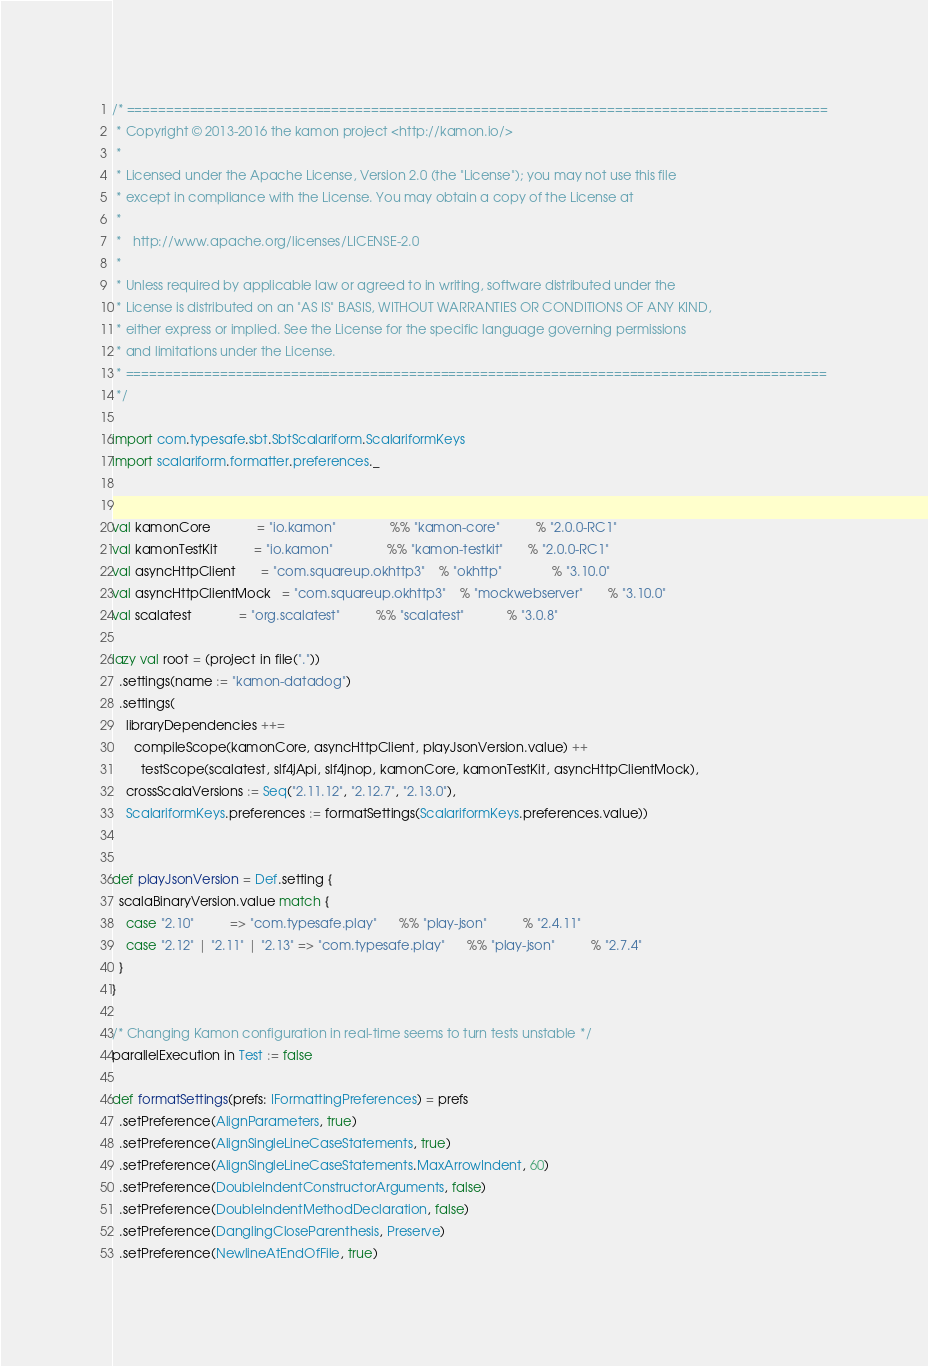<code> <loc_0><loc_0><loc_500><loc_500><_Scala_>/* =========================================================================================
 * Copyright © 2013-2016 the kamon project <http://kamon.io/>
 *
 * Licensed under the Apache License, Version 2.0 (the "License"); you may not use this file
 * except in compliance with the License. You may obtain a copy of the License at
 *
 *   http://www.apache.org/licenses/LICENSE-2.0
 *
 * Unless required by applicable law or agreed to in writing, software distributed under the
 * License is distributed on an "AS IS" BASIS, WITHOUT WARRANTIES OR CONDITIONS OF ANY KIND,
 * either express or implied. See the License for the specific language governing permissions
 * and limitations under the License.
 * =========================================================================================
 */

import com.typesafe.sbt.SbtScalariform.ScalariformKeys
import scalariform.formatter.preferences._


val kamonCore             = "io.kamon"               %% "kamon-core"          % "2.0.0-RC1"
val kamonTestKit          = "io.kamon"               %% "kamon-testkit"       % "2.0.0-RC1"
val asyncHttpClient       = "com.squareup.okhttp3"    % "okhttp"              % "3.10.0"
val asyncHttpClientMock   = "com.squareup.okhttp3"    % "mockwebserver"       % "3.10.0"
val scalatest             = "org.scalatest"          %% "scalatest"            % "3.0.8"

lazy val root = (project in file("."))
  .settings(name := "kamon-datadog")
  .settings(
    libraryDependencies ++=
      compileScope(kamonCore, asyncHttpClient, playJsonVersion.value) ++
        testScope(scalatest, slf4jApi, slf4jnop, kamonCore, kamonTestKit, asyncHttpClientMock),
    crossScalaVersions := Seq("2.11.12", "2.12.7", "2.13.0"),
    ScalariformKeys.preferences := formatSettings(ScalariformKeys.preferences.value))


def playJsonVersion = Def.setting {
  scalaBinaryVersion.value match {
    case "2.10"          => "com.typesafe.play"      %% "play-json"          % "2.4.11"
    case "2.12" | "2.11" | "2.13" => "com.typesafe.play"      %% "play-json"          % "2.7.4"
  }
}

/* Changing Kamon configuration in real-time seems to turn tests unstable */
parallelExecution in Test := false

def formatSettings(prefs: IFormattingPreferences) = prefs
  .setPreference(AlignParameters, true)
  .setPreference(AlignSingleLineCaseStatements, true)
  .setPreference(AlignSingleLineCaseStatements.MaxArrowIndent, 60)
  .setPreference(DoubleIndentConstructorArguments, false)
  .setPreference(DoubleIndentMethodDeclaration, false)
  .setPreference(DanglingCloseParenthesis, Preserve)
  .setPreference(NewlineAtEndOfFile, true)
</code> 